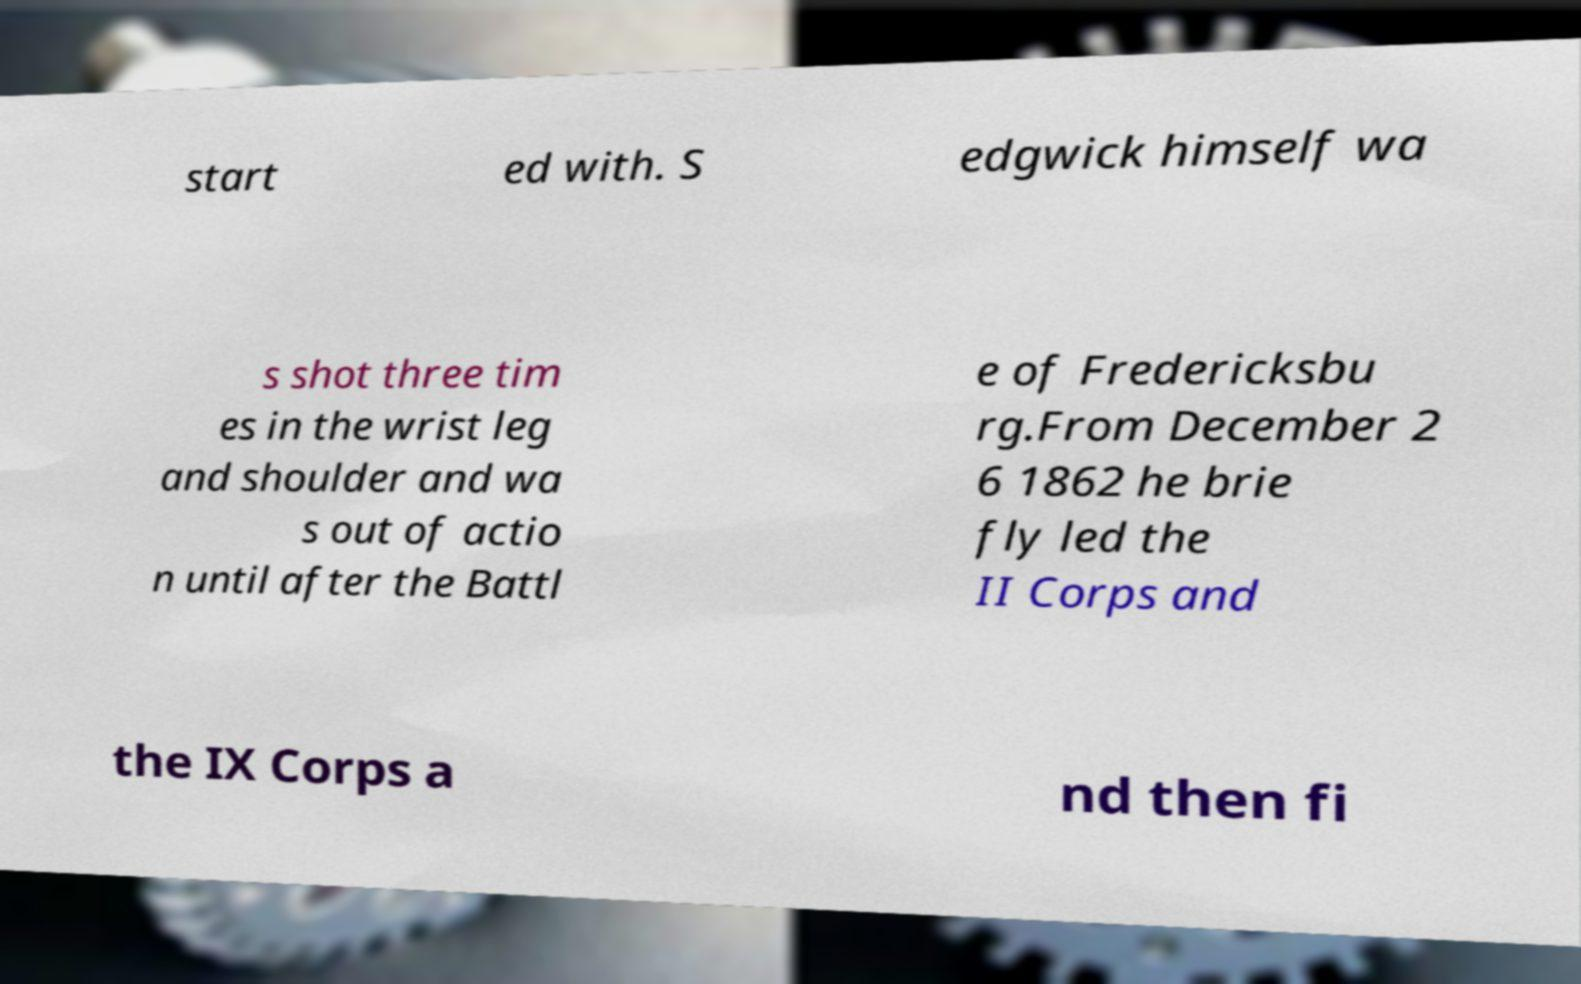Please identify and transcribe the text found in this image. start ed with. S edgwick himself wa s shot three tim es in the wrist leg and shoulder and wa s out of actio n until after the Battl e of Fredericksbu rg.From December 2 6 1862 he brie fly led the II Corps and the IX Corps a nd then fi 